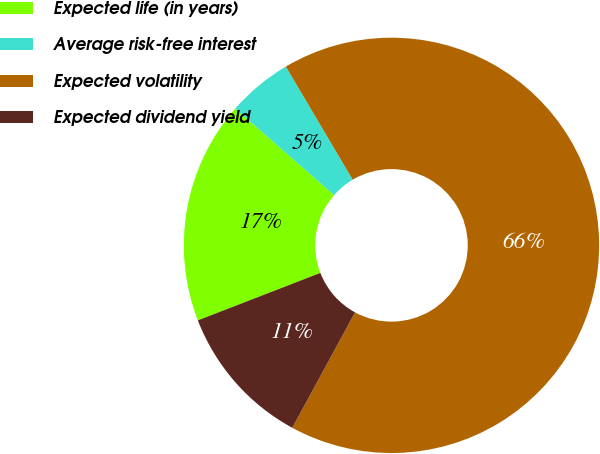<chart> <loc_0><loc_0><loc_500><loc_500><pie_chart><fcel>Expected life (in years)<fcel>Average risk-free interest<fcel>Expected volatility<fcel>Expected dividend yield<nl><fcel>17.33%<fcel>5.06%<fcel>66.42%<fcel>11.19%<nl></chart> 